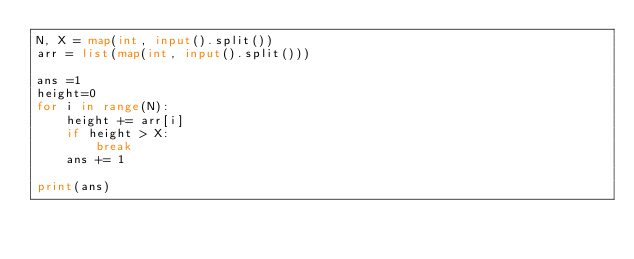Convert code to text. <code><loc_0><loc_0><loc_500><loc_500><_Python_>N, X = map(int, input().split())
arr = list(map(int, input().split()))

ans =1
height=0
for i in range(N):
    height += arr[i]
    if height > X:
        break
    ans += 1

print(ans)
</code> 